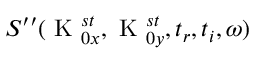<formula> <loc_0><loc_0><loc_500><loc_500>S ^ { \prime \prime } ( K _ { 0 x } ^ { s t } , K _ { 0 y } ^ { s t } , t _ { r } , t _ { i } , \omega )</formula> 